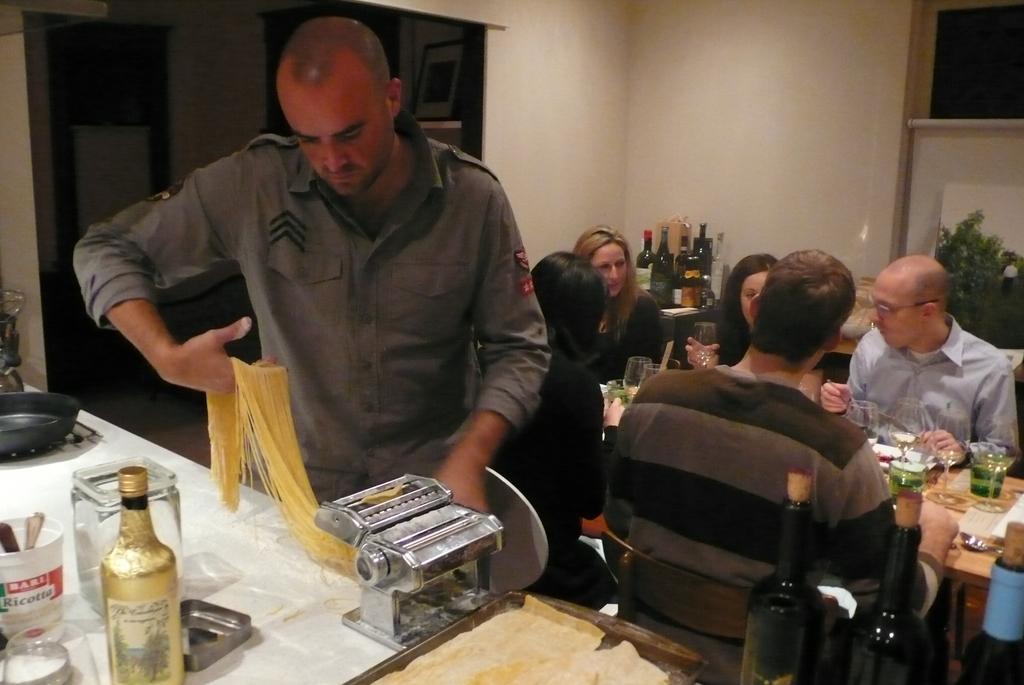Describe this image in one or two sentences. In this image we can see a man working with machine. We can see bottles, jars, pan and somethings on table. In the background we can see people sitting on chairs near table on which plates and glasses are placed. 